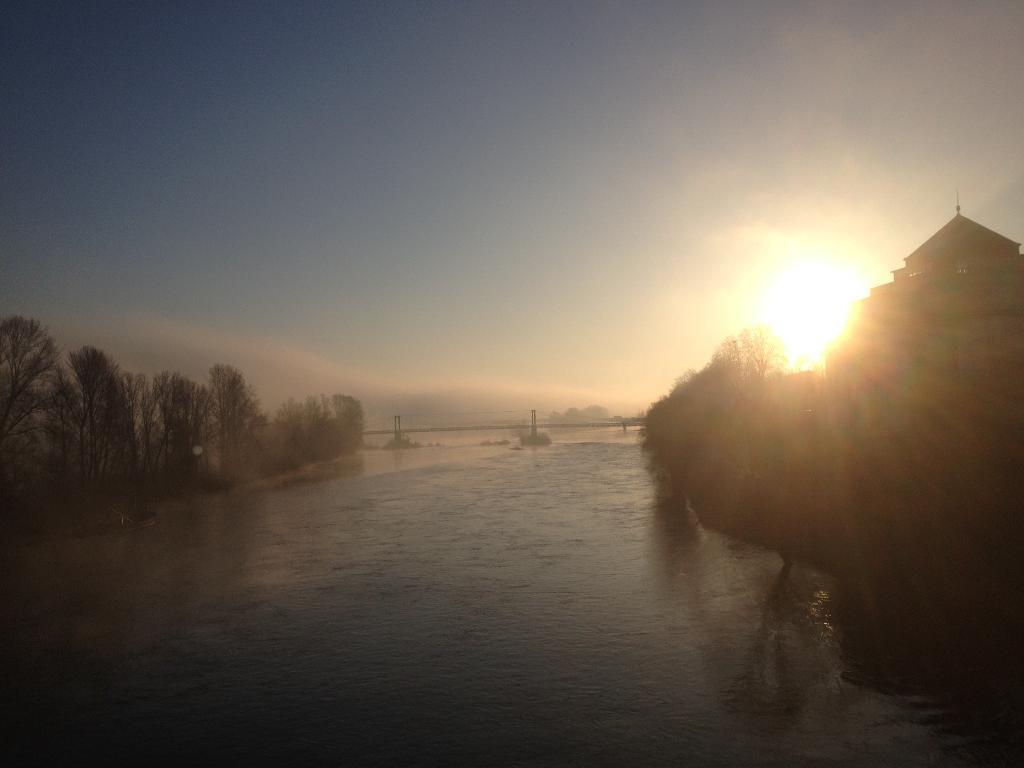What is the main structure in the center of the image? There is a bridge in the center of the image. What can be seen in the foreground of the image? There is water visible in the foreground. What type of vegetation is in the background of the image? There is a group of trees in the background. What else can be seen in the background of the image? There is at least one building in the background. What is the condition of the sky in the image? The sun is visible in the sky. How many cherries are hanging from the bridge in the image? There are no cherries present in the image, as it features a bridge, water, trees, a building, and a sunny sky. What color is the passenger's hat in the image? There is no passenger present in the image, so it is not possible to determine the color of their hat. 